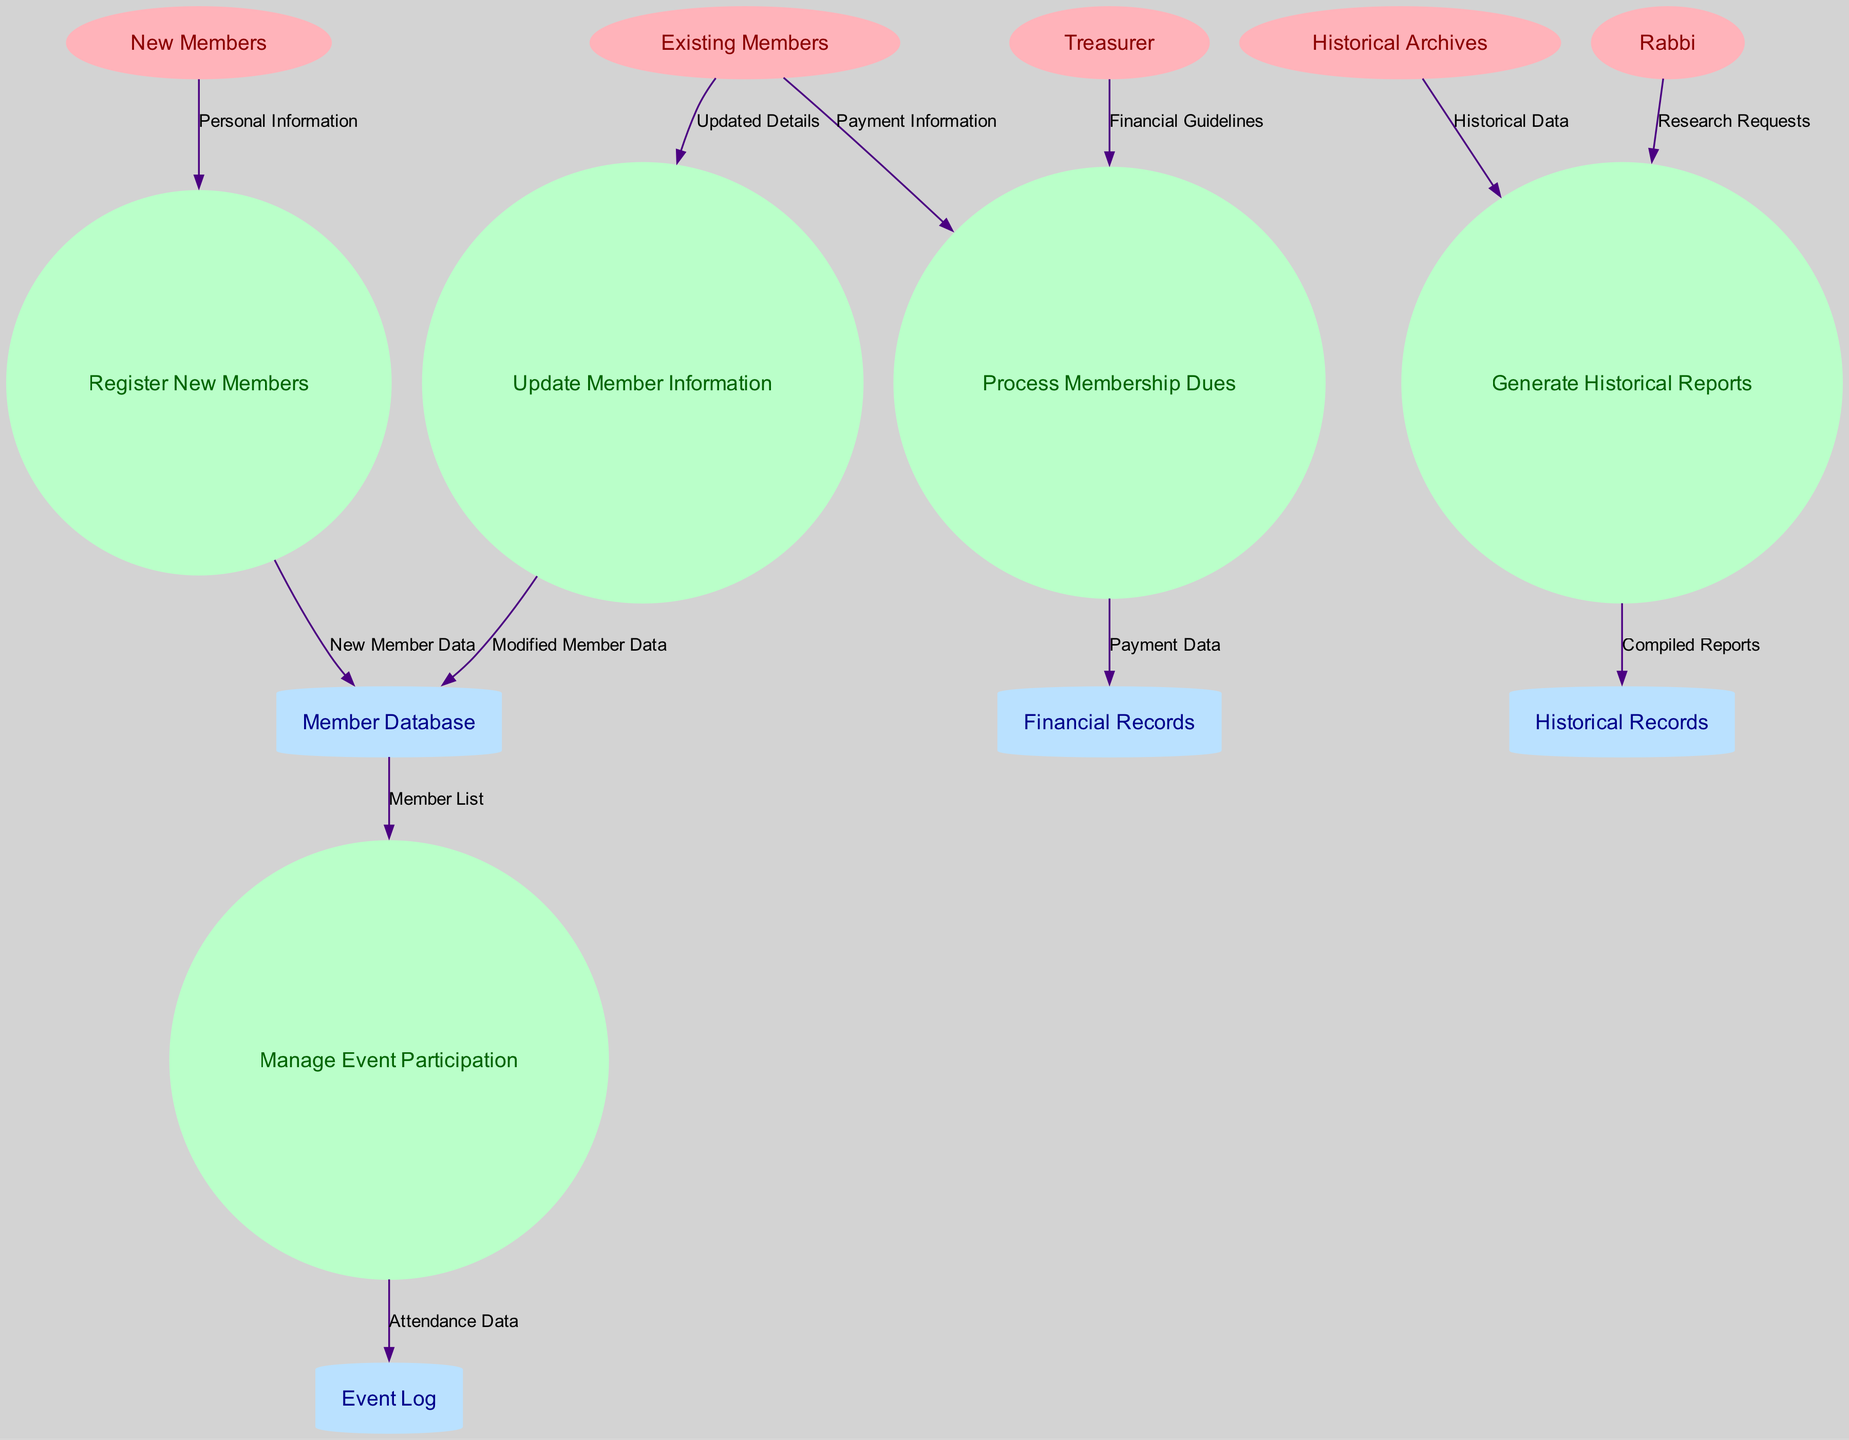What are the external entities in this diagram? The external entities are the nodes that interact with the system but are not part of it. They include New Members, Existing Members, Historical Archives, Rabbi, and Treasurer. Each serves a specific role in the membership registration and management process.
Answer: New Members, Existing Members, Historical Archives, Rabbi, Treasurer How many processes are defined in the diagram? The processes are shown as circles in the diagram. By counting the circles provided, we find that there are a total of five processes listed: Register New Members, Update Member Information, Process Membership Dues, Generate Historical Reports, and Manage Event Participation.
Answer: 5 Which process generates historical reports? By looking at the list of processes in the diagram, "Generate Historical Reports" is explicitly stated as one of the processes, indicating its role in compiling and providing historical data.
Answer: Generate Historical Reports What data flows from Existing Members to the Financial Records? The data that flows from Existing Members to the Financial Records is labeled as "Payment Data," indicating that this information is about the dues payments made by existing members.
Answer: Payment Data What external entity sends research requests to generate historical reports? The diagram indicates that the "Rabbi" is the external entity that sends "Research Requests" to the "Generate Historical Reports" process, facilitating the creation of reports based on specific inquiries.
Answer: Rabbi Which data store is filled with new member data? The "Member Database" receives the "New Member Data" from the "Register New Members" process, thereby organizing and storing all information related to newly registered members.
Answer: Member Database How does the Treasurer contribute to the Process Membership Dues? The Treasurer provides the "Financial Guidelines," which are important for the "Process Membership Dues," ensuring that dues are processed according to the congregation's financial rules and standards.
Answer: Financial Guidelines What flows from the Manage Event Participation to the Event Log? The data labeled as "Attendance Data" flows from "Manage Event Participation" to the "Event Log," indicating the recording of member attendance at various events.
Answer: Attendance Data Which data store holds historical data generated by processes? The "Historical Records" data store holds the data that is compiled by the "Generate Historical Reports" process, containing all past reports and related historical information for reference.
Answer: Historical Records 